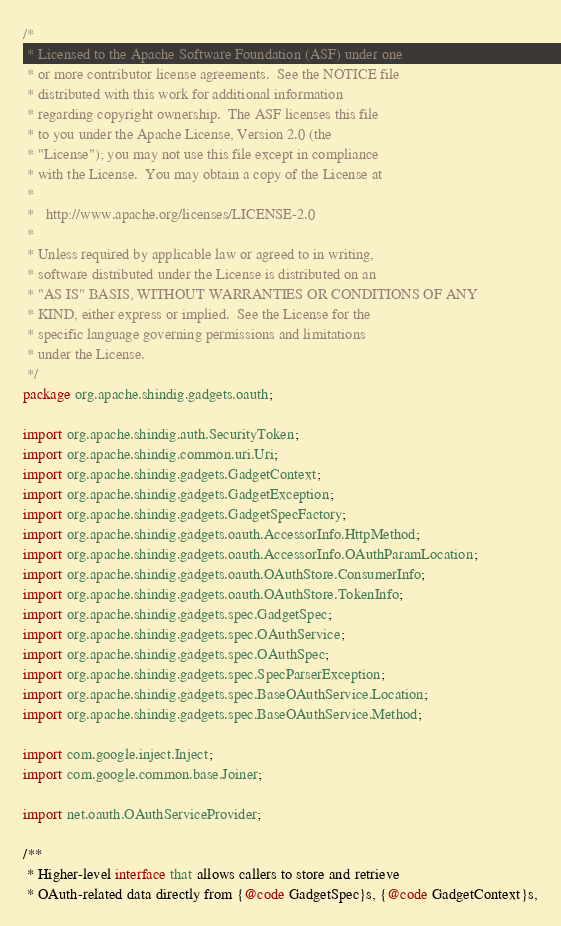Convert code to text. <code><loc_0><loc_0><loc_500><loc_500><_Java_>/*
 * Licensed to the Apache Software Foundation (ASF) under one
 * or more contributor license agreements.  See the NOTICE file
 * distributed with this work for additional information
 * regarding copyright ownership.  The ASF licenses this file
 * to you under the Apache License, Version 2.0 (the
 * "License"); you may not use this file except in compliance
 * with the License.  You may obtain a copy of the License at
 *
 *   http://www.apache.org/licenses/LICENSE-2.0
 *
 * Unless required by applicable law or agreed to in writing,
 * software distributed under the License is distributed on an
 * "AS IS" BASIS, WITHOUT WARRANTIES OR CONDITIONS OF ANY
 * KIND, either express or implied.  See the License for the
 * specific language governing permissions and limitations
 * under the License.
 */
package org.apache.shindig.gadgets.oauth;

import org.apache.shindig.auth.SecurityToken;
import org.apache.shindig.common.uri.Uri;
import org.apache.shindig.gadgets.GadgetContext;
import org.apache.shindig.gadgets.GadgetException;
import org.apache.shindig.gadgets.GadgetSpecFactory;
import org.apache.shindig.gadgets.oauth.AccessorInfo.HttpMethod;
import org.apache.shindig.gadgets.oauth.AccessorInfo.OAuthParamLocation;
import org.apache.shindig.gadgets.oauth.OAuthStore.ConsumerInfo;
import org.apache.shindig.gadgets.oauth.OAuthStore.TokenInfo;
import org.apache.shindig.gadgets.spec.GadgetSpec;
import org.apache.shindig.gadgets.spec.OAuthService;
import org.apache.shindig.gadgets.spec.OAuthSpec;
import org.apache.shindig.gadgets.spec.SpecParserException;
import org.apache.shindig.gadgets.spec.BaseOAuthService.Location;
import org.apache.shindig.gadgets.spec.BaseOAuthService.Method;

import com.google.inject.Inject;
import com.google.common.base.Joiner;

import net.oauth.OAuthServiceProvider;

/**
 * Higher-level interface that allows callers to store and retrieve
 * OAuth-related data directly from {@code GadgetSpec}s, {@code GadgetContext}s,</code> 